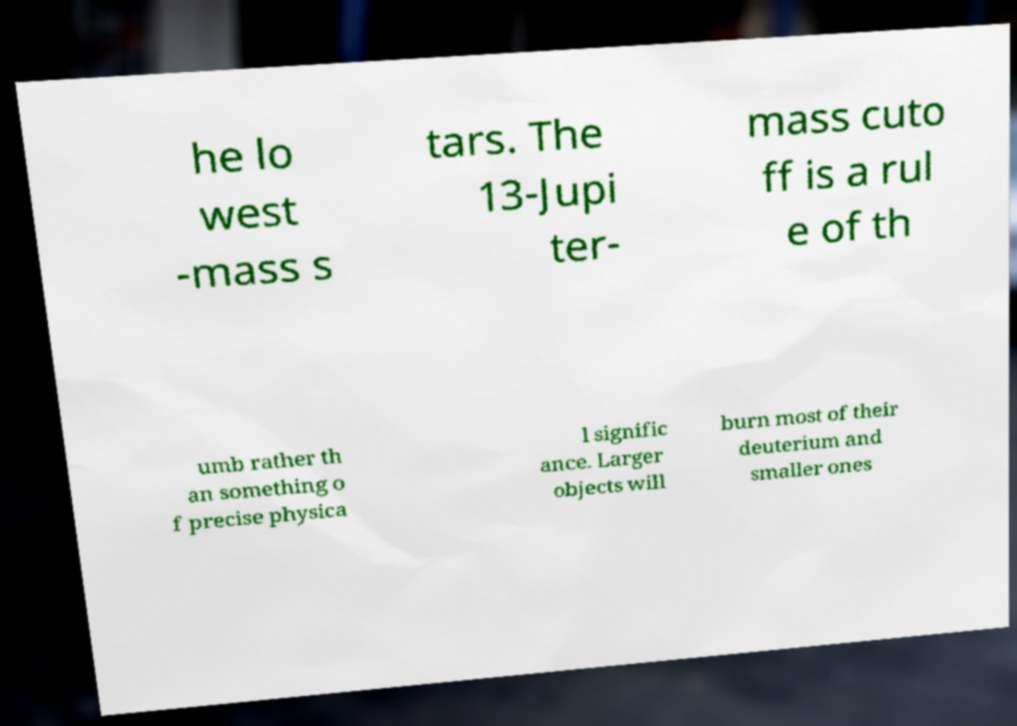Please identify and transcribe the text found in this image. he lo west -mass s tars. The 13-Jupi ter- mass cuto ff is a rul e of th umb rather th an something o f precise physica l signific ance. Larger objects will burn most of their deuterium and smaller ones 